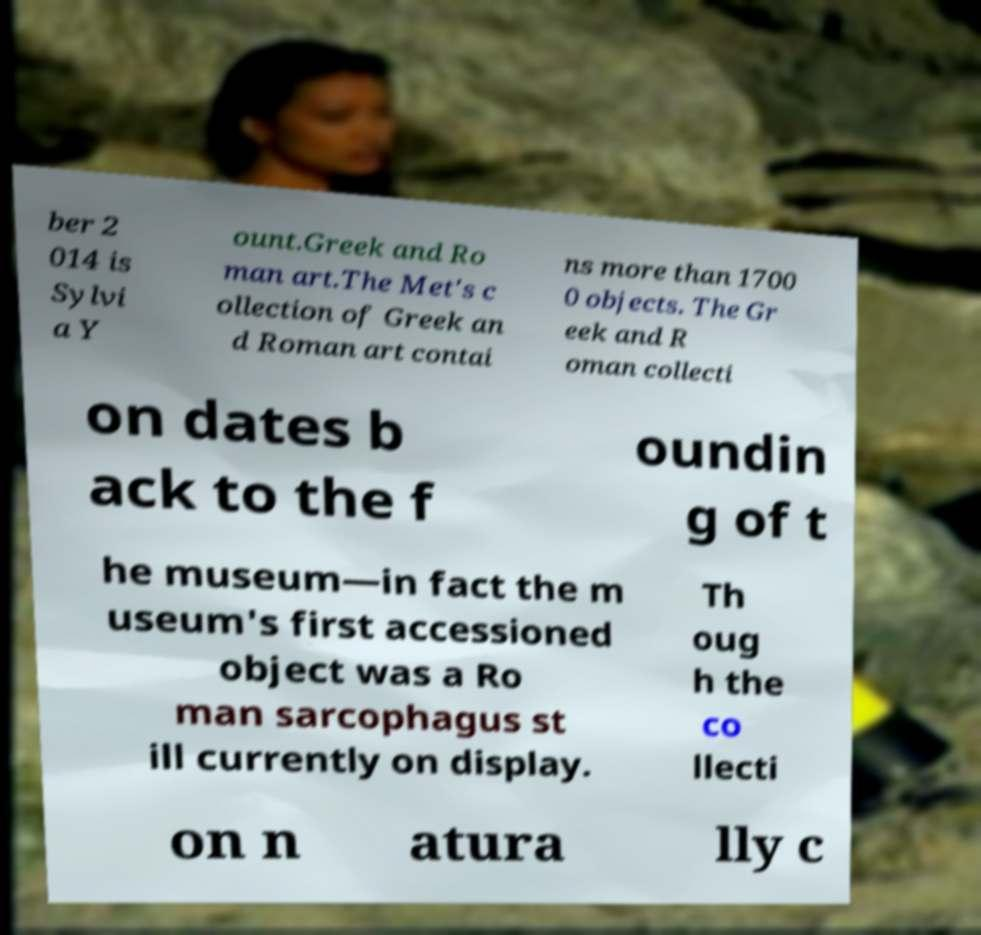Please identify and transcribe the text found in this image. ber 2 014 is Sylvi a Y ount.Greek and Ro man art.The Met's c ollection of Greek an d Roman art contai ns more than 1700 0 objects. The Gr eek and R oman collecti on dates b ack to the f oundin g of t he museum—in fact the m useum's first accessioned object was a Ro man sarcophagus st ill currently on display. Th oug h the co llecti on n atura lly c 